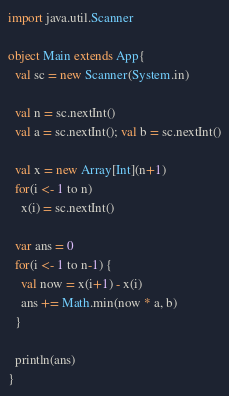<code> <loc_0><loc_0><loc_500><loc_500><_Scala_>import java.util.Scanner

object Main extends App{
  val sc = new Scanner(System.in)

  val n = sc.nextInt()
  val a = sc.nextInt(); val b = sc.nextInt()

  val x = new Array[Int](n+1)
  for(i <- 1 to n)
    x(i) = sc.nextInt()

  var ans = 0
  for(i <- 1 to n-1) {
    val now = x(i+1) - x(i)
    ans += Math.min(now * a, b)
  }

  println(ans)
}
</code> 